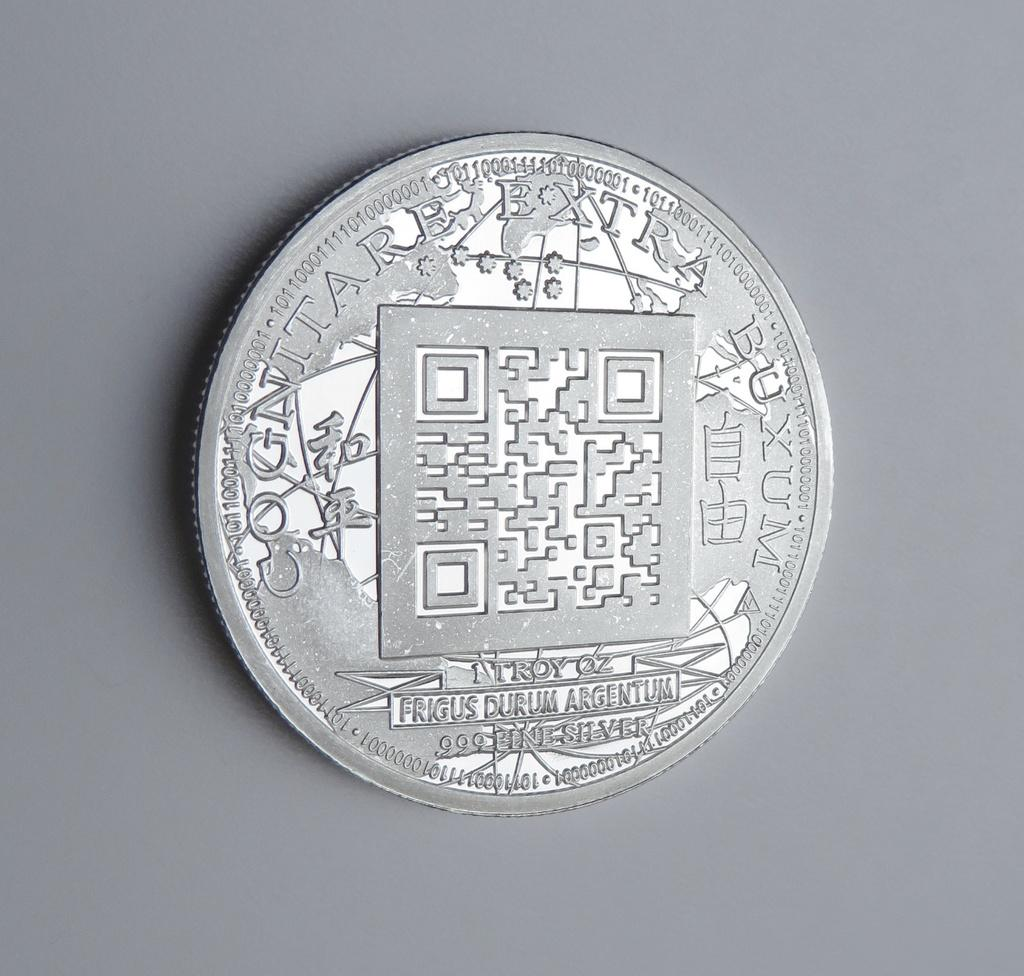<image>
Offer a succinct explanation of the picture presented. A shiny silver coin says 1 Troy OZ under a square in the center. 